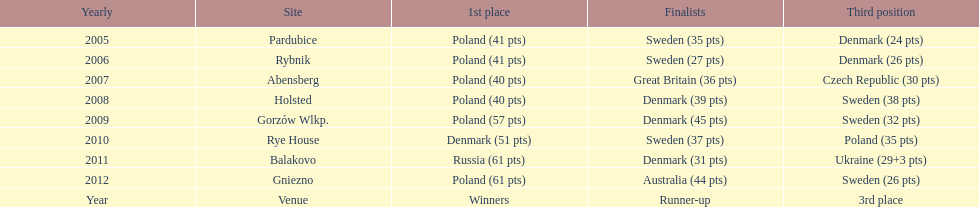After their first place win in 2009, how did poland place the next year at the speedway junior world championship? 3rd place. 